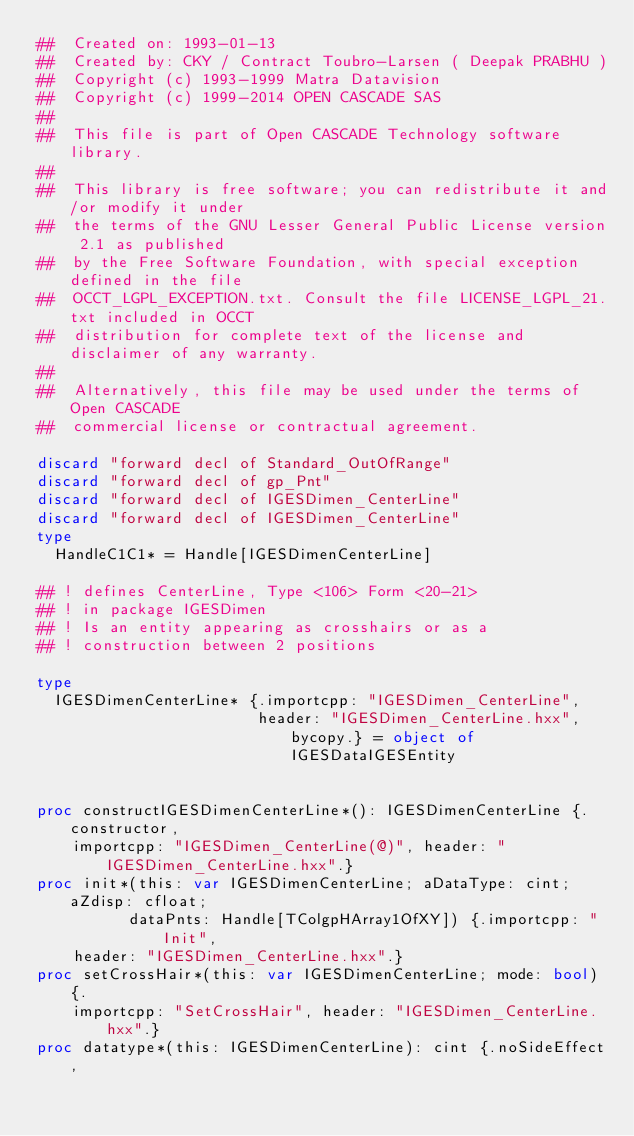Convert code to text. <code><loc_0><loc_0><loc_500><loc_500><_Nim_>##  Created on: 1993-01-13
##  Created by: CKY / Contract Toubro-Larsen ( Deepak PRABHU )
##  Copyright (c) 1993-1999 Matra Datavision
##  Copyright (c) 1999-2014 OPEN CASCADE SAS
##
##  This file is part of Open CASCADE Technology software library.
##
##  This library is free software; you can redistribute it and/or modify it under
##  the terms of the GNU Lesser General Public License version 2.1 as published
##  by the Free Software Foundation, with special exception defined in the file
##  OCCT_LGPL_EXCEPTION.txt. Consult the file LICENSE_LGPL_21.txt included in OCCT
##  distribution for complete text of the license and disclaimer of any warranty.
##
##  Alternatively, this file may be used under the terms of Open CASCADE
##  commercial license or contractual agreement.

discard "forward decl of Standard_OutOfRange"
discard "forward decl of gp_Pnt"
discard "forward decl of IGESDimen_CenterLine"
discard "forward decl of IGESDimen_CenterLine"
type
  HandleC1C1* = Handle[IGESDimenCenterLine]

## ! defines CenterLine, Type <106> Form <20-21>
## ! in package IGESDimen
## ! Is an entity appearing as crosshairs or as a
## ! construction between 2 positions

type
  IGESDimenCenterLine* {.importcpp: "IGESDimen_CenterLine",
                        header: "IGESDimen_CenterLine.hxx", bycopy.} = object of IGESDataIGESEntity


proc constructIGESDimenCenterLine*(): IGESDimenCenterLine {.constructor,
    importcpp: "IGESDimen_CenterLine(@)", header: "IGESDimen_CenterLine.hxx".}
proc init*(this: var IGESDimenCenterLine; aDataType: cint; aZdisp: cfloat;
          dataPnts: Handle[TColgpHArray1OfXY]) {.importcpp: "Init",
    header: "IGESDimen_CenterLine.hxx".}
proc setCrossHair*(this: var IGESDimenCenterLine; mode: bool) {.
    importcpp: "SetCrossHair", header: "IGESDimen_CenterLine.hxx".}
proc datatype*(this: IGESDimenCenterLine): cint {.noSideEffect,</code> 